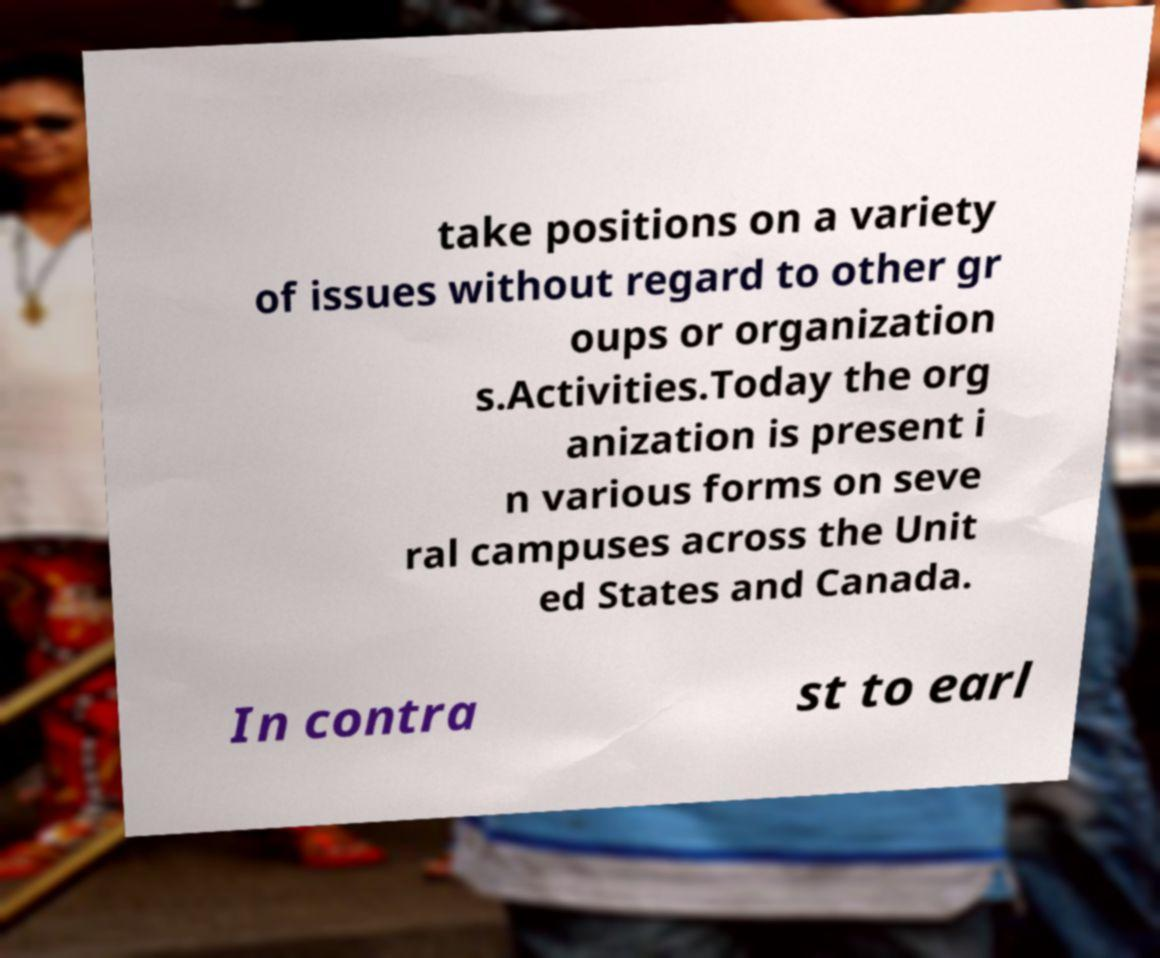For documentation purposes, I need the text within this image transcribed. Could you provide that? take positions on a variety of issues without regard to other gr oups or organization s.Activities.Today the org anization is present i n various forms on seve ral campuses across the Unit ed States and Canada. In contra st to earl 